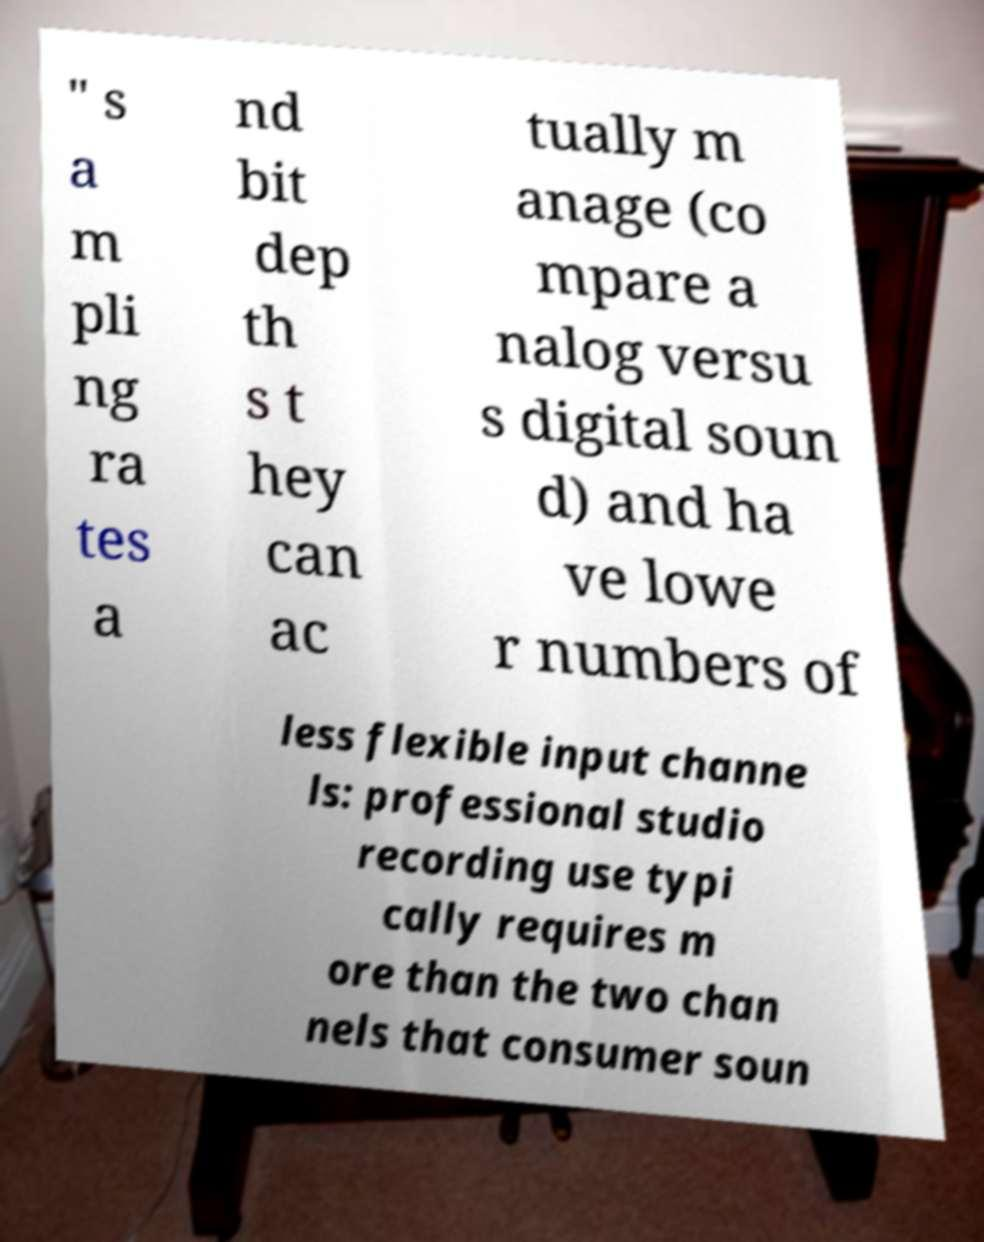There's text embedded in this image that I need extracted. Can you transcribe it verbatim? " s a m pli ng ra tes a nd bit dep th s t hey can ac tually m anage (co mpare a nalog versu s digital soun d) and ha ve lowe r numbers of less flexible input channe ls: professional studio recording use typi cally requires m ore than the two chan nels that consumer soun 